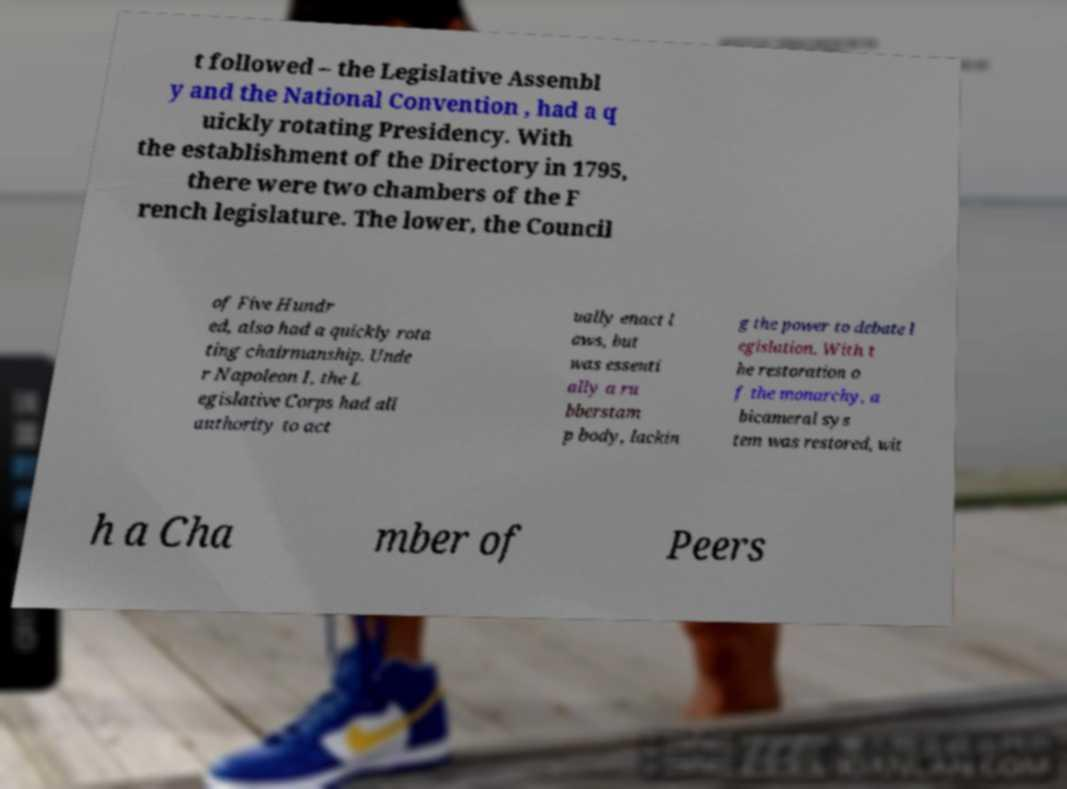There's text embedded in this image that I need extracted. Can you transcribe it verbatim? t followed – the Legislative Assembl y and the National Convention , had a q uickly rotating Presidency. With the establishment of the Directory in 1795, there were two chambers of the F rench legislature. The lower, the Council of Five Hundr ed, also had a quickly rota ting chairmanship. Unde r Napoleon I, the L egislative Corps had all authority to act ually enact l aws, but was essenti ally a ru bberstam p body, lackin g the power to debate l egislation. With t he restoration o f the monarchy, a bicameral sys tem was restored, wit h a Cha mber of Peers 